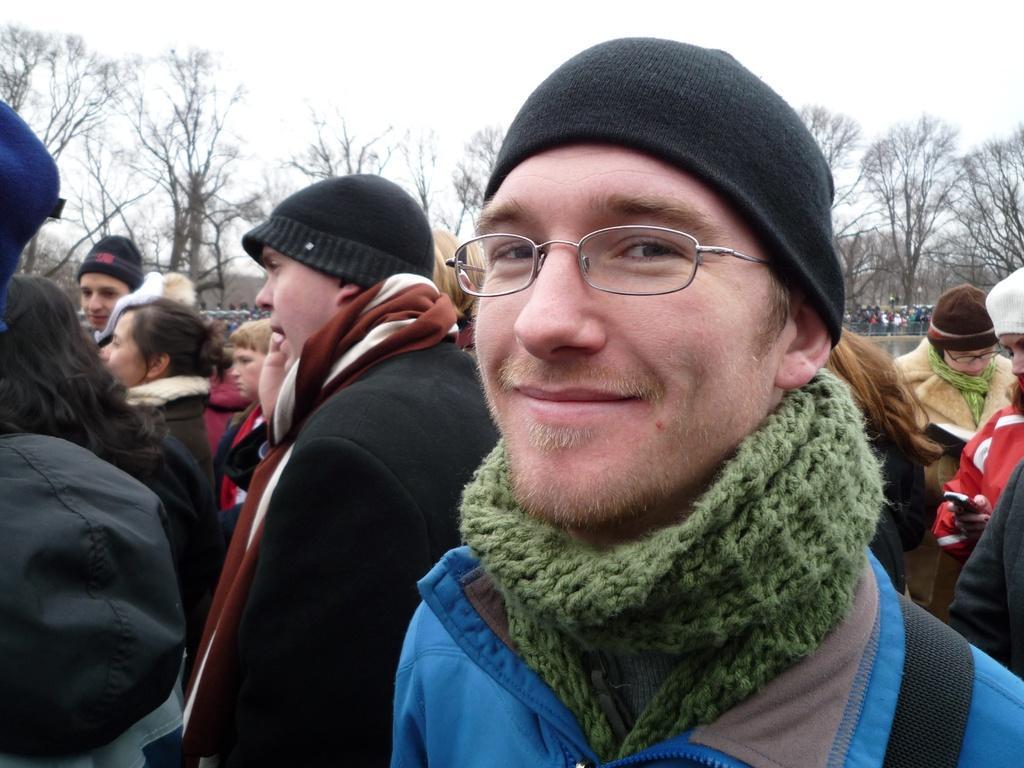Can you describe this image briefly? This image consists of many people. In the front, the man laughing is wearing a blue jacket and green scarf. At the top, there is sky. In the background, there are trees. He is also wearing a black cap. 